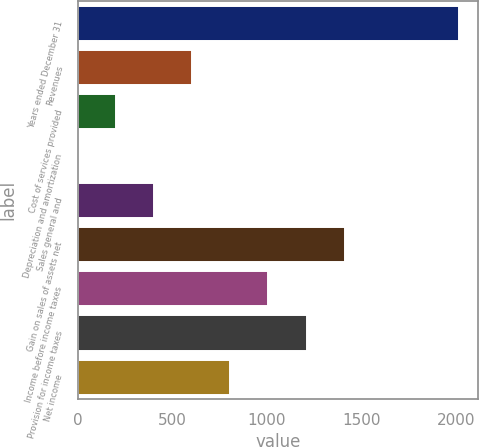Convert chart to OTSL. <chart><loc_0><loc_0><loc_500><loc_500><bar_chart><fcel>Years ended December 31<fcel>Revenues<fcel>Cost of services provided<fcel>Depreciation and amortization<fcel>Sales general and<fcel>Gain on sales of assets net<fcel>Income before income taxes<fcel>Provision for income taxes<fcel>Net income<nl><fcel>2015<fcel>606.11<fcel>203.57<fcel>2.3<fcel>404.84<fcel>1411.19<fcel>1008.65<fcel>1209.92<fcel>807.38<nl></chart> 